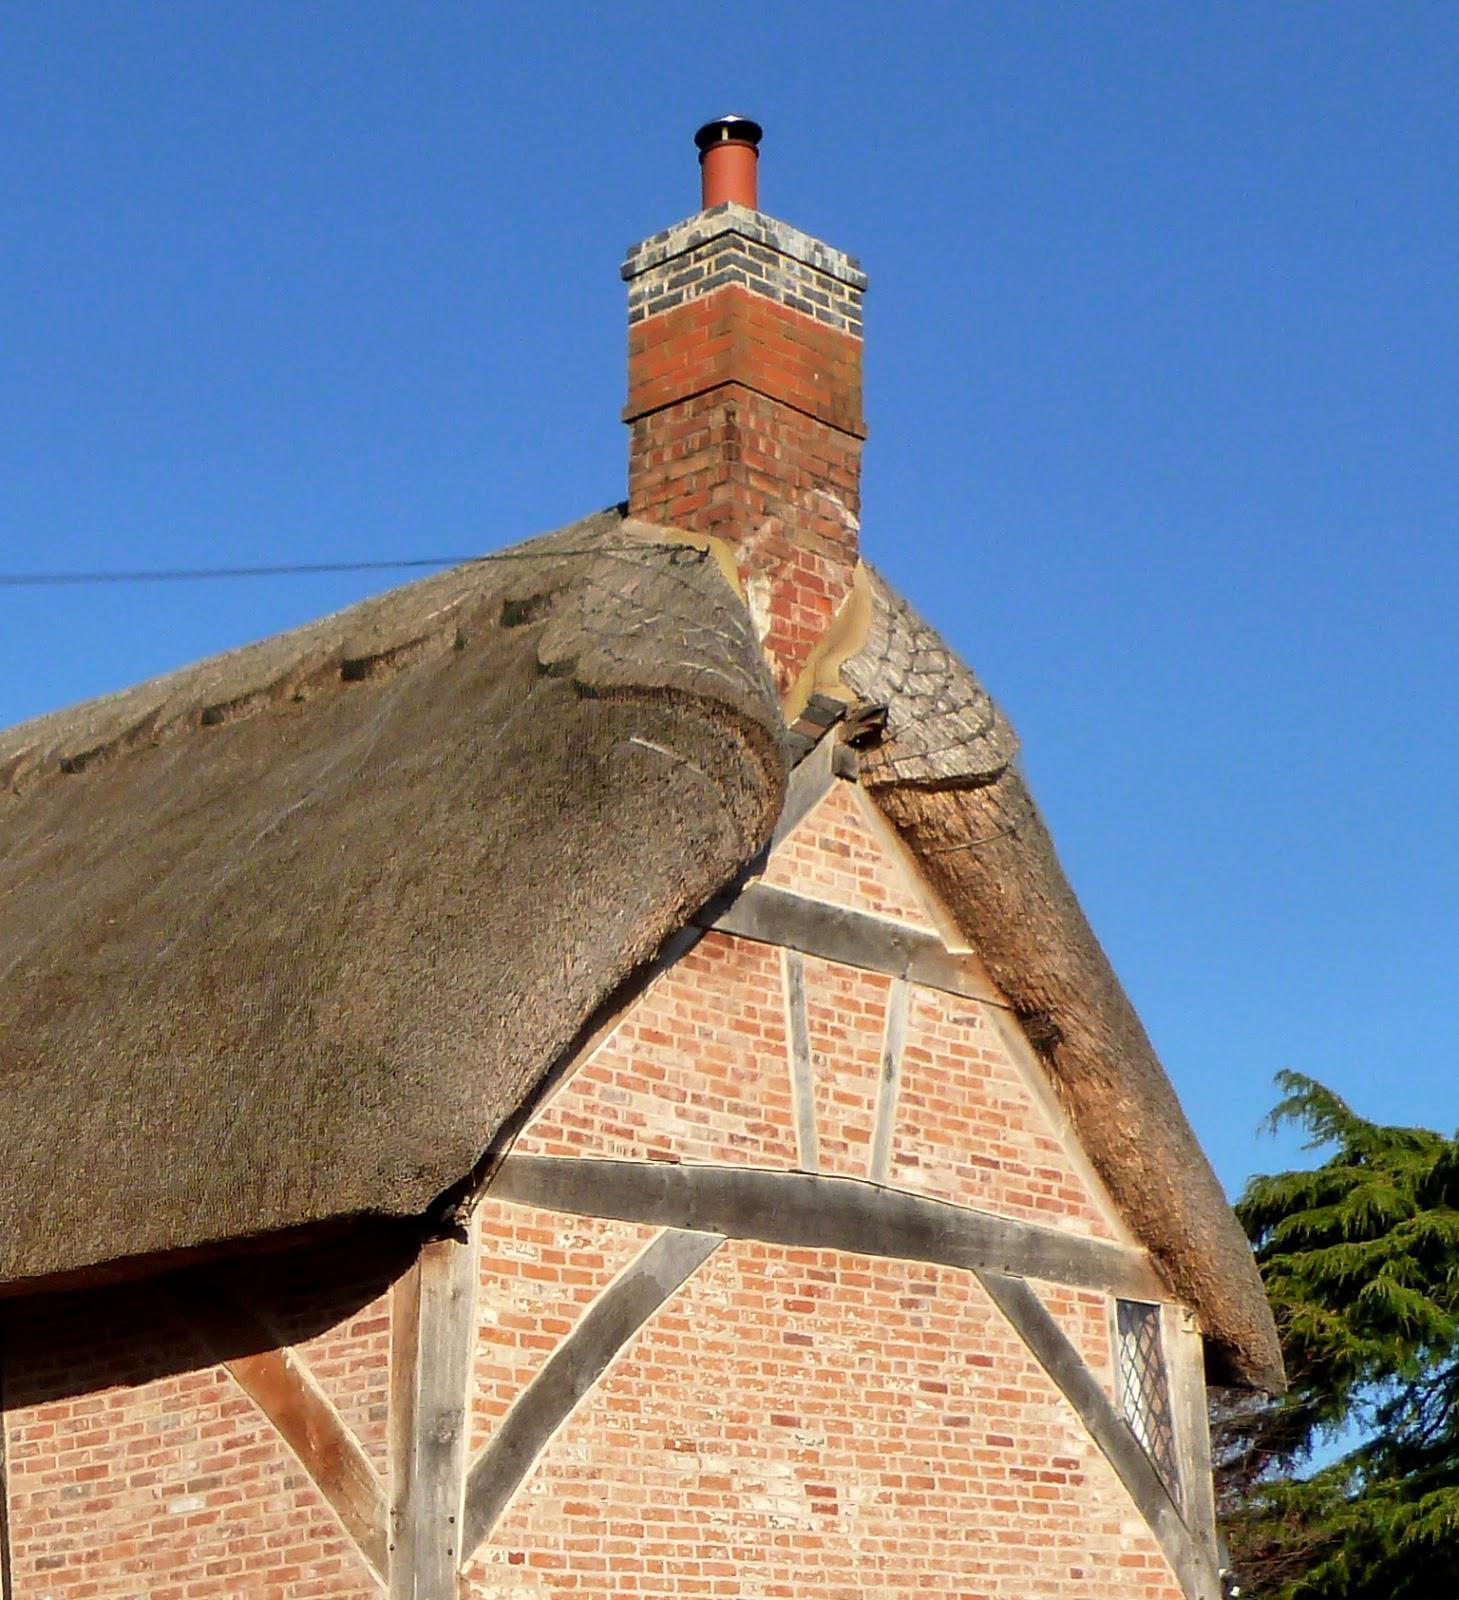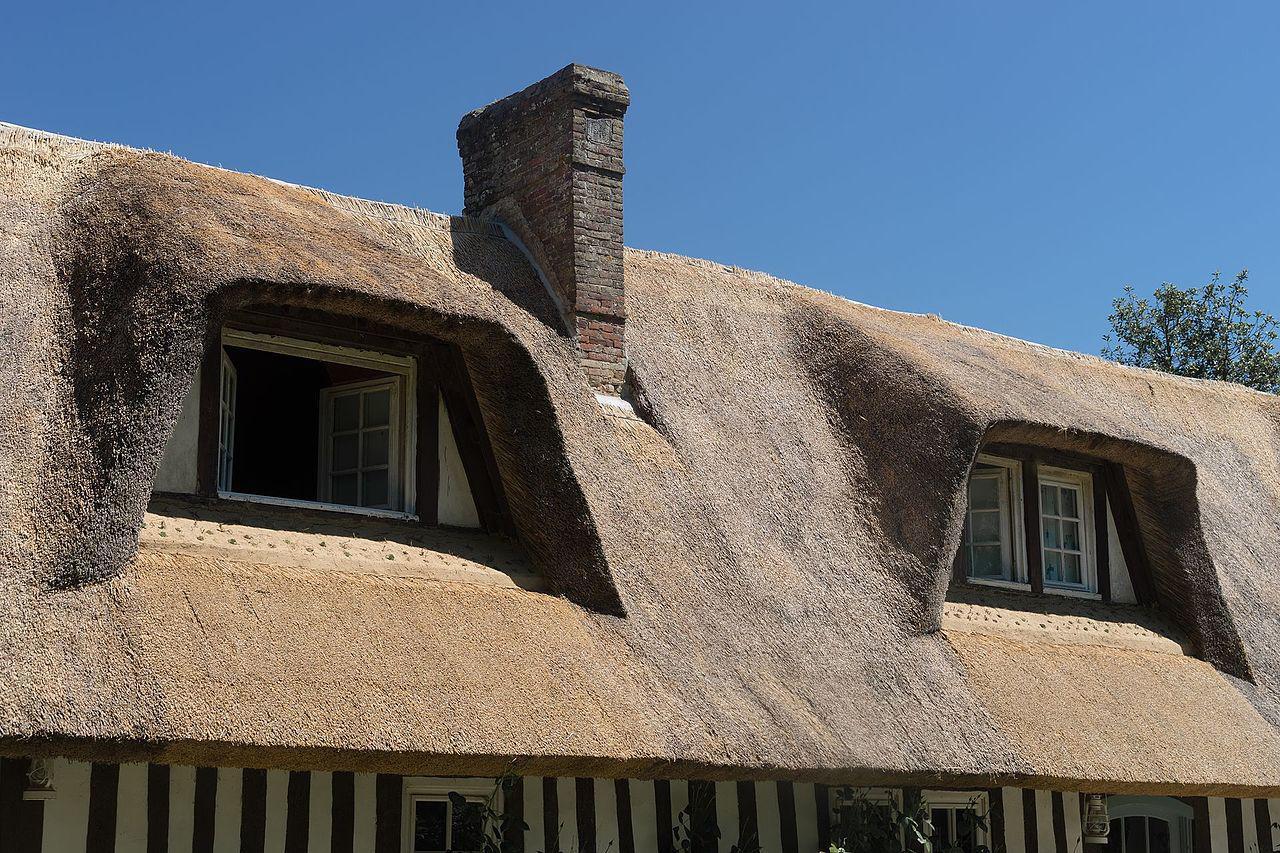The first image is the image on the left, the second image is the image on the right. Analyze the images presented: Is the assertion "One image shows a chimney with a sculptural scalloped border around it, and the other image includes two sets of windows with a thick gray roof that curves around and completely overhangs them." valid? Answer yes or no. Yes. The first image is the image on the left, the second image is the image on the right. For the images shown, is this caption "One of the houses has two chimneys." true? Answer yes or no. No. 